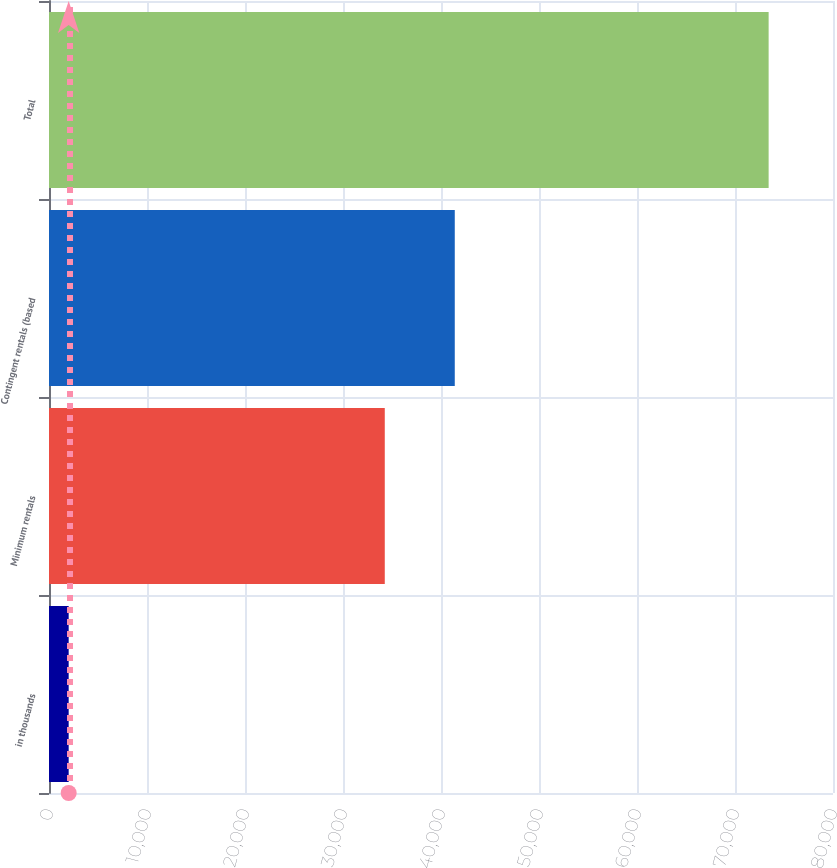Convert chart to OTSL. <chart><loc_0><loc_0><loc_500><loc_500><bar_chart><fcel>in thousands<fcel>Minimum rentals<fcel>Contingent rentals (based<fcel>Total<nl><fcel>2008<fcel>34263<fcel>41405.4<fcel>73432<nl></chart> 